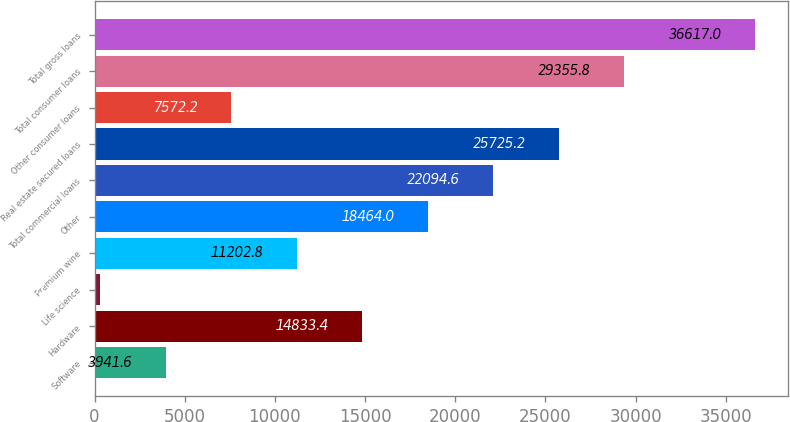Convert chart to OTSL. <chart><loc_0><loc_0><loc_500><loc_500><bar_chart><fcel>Software<fcel>Hardware<fcel>Life science<fcel>Premium wine<fcel>Other<fcel>Total commercial loans<fcel>Real estate secured loans<fcel>Other consumer loans<fcel>Total consumer loans<fcel>Total gross loans<nl><fcel>3941.6<fcel>14833.4<fcel>311<fcel>11202.8<fcel>18464<fcel>22094.6<fcel>25725.2<fcel>7572.2<fcel>29355.8<fcel>36617<nl></chart> 